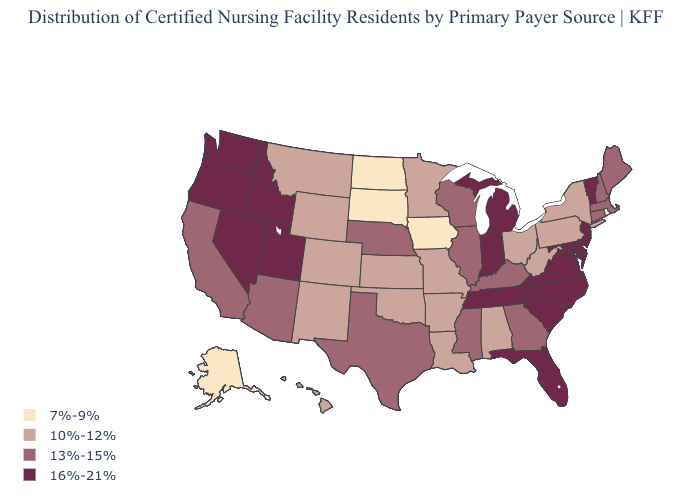Does the map have missing data?
Write a very short answer. No. Which states have the lowest value in the Northeast?
Concise answer only. Rhode Island. What is the value of Alabama?
Answer briefly. 10%-12%. Which states hav the highest value in the South?
Short answer required. Delaware, Florida, Maryland, North Carolina, South Carolina, Tennessee, Virginia. Name the states that have a value in the range 16%-21%?
Keep it brief. Delaware, Florida, Idaho, Indiana, Maryland, Michigan, Nevada, New Jersey, North Carolina, Oregon, South Carolina, Tennessee, Utah, Vermont, Virginia, Washington. What is the value of Rhode Island?
Give a very brief answer. 7%-9%. Is the legend a continuous bar?
Short answer required. No. What is the value of New Hampshire?
Quick response, please. 13%-15%. Among the states that border Pennsylvania , does New York have the highest value?
Be succinct. No. Does the map have missing data?
Give a very brief answer. No. Does Maryland have a higher value than Georgia?
Concise answer only. Yes. Name the states that have a value in the range 10%-12%?
Concise answer only. Alabama, Arkansas, Colorado, Hawaii, Kansas, Louisiana, Minnesota, Missouri, Montana, New Mexico, New York, Ohio, Oklahoma, Pennsylvania, West Virginia, Wyoming. How many symbols are there in the legend?
Give a very brief answer. 4. Which states have the highest value in the USA?
Concise answer only. Delaware, Florida, Idaho, Indiana, Maryland, Michigan, Nevada, New Jersey, North Carolina, Oregon, South Carolina, Tennessee, Utah, Vermont, Virginia, Washington. Name the states that have a value in the range 10%-12%?
Give a very brief answer. Alabama, Arkansas, Colorado, Hawaii, Kansas, Louisiana, Minnesota, Missouri, Montana, New Mexico, New York, Ohio, Oklahoma, Pennsylvania, West Virginia, Wyoming. 